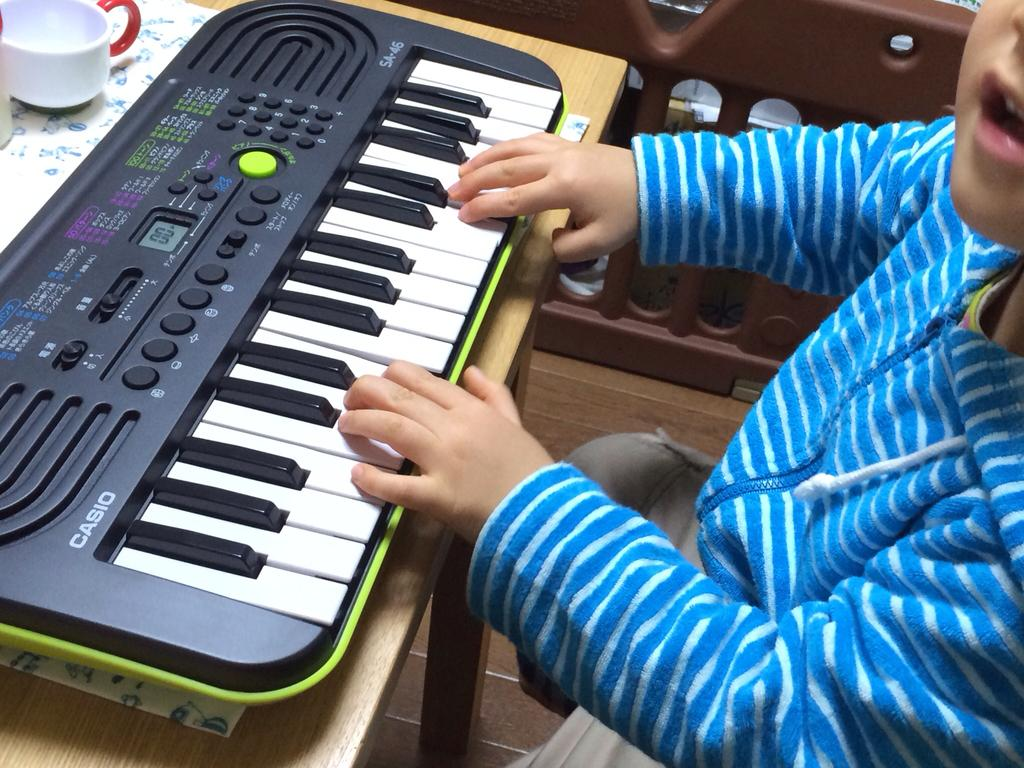What is the kid doing in the image? The kid is sitting in a chair in the image. What is located behind the kid? The kid is in front of a piano. How is the piano positioned in the image? The piano is placed on a table. What other objects are on the table? There is a cup and a paper on the table. What type of scarecrow is standing next to the piano in the image? There is no scarecrow present in the image; it features a kid sitting in a chair in front of a piano placed on a table. 